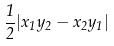<formula> <loc_0><loc_0><loc_500><loc_500>\frac { 1 } { 2 } | x _ { 1 } y _ { 2 } - x _ { 2 } y _ { 1 } |</formula> 